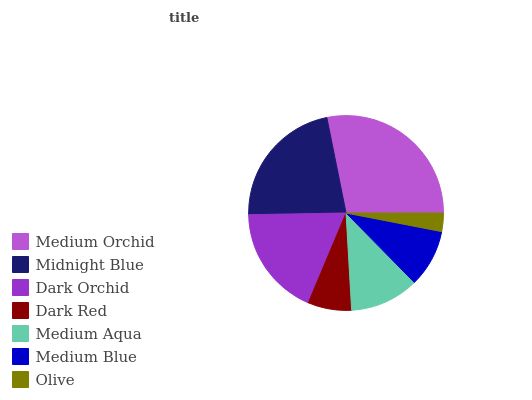Is Olive the minimum?
Answer yes or no. Yes. Is Medium Orchid the maximum?
Answer yes or no. Yes. Is Midnight Blue the minimum?
Answer yes or no. No. Is Midnight Blue the maximum?
Answer yes or no. No. Is Medium Orchid greater than Midnight Blue?
Answer yes or no. Yes. Is Midnight Blue less than Medium Orchid?
Answer yes or no. Yes. Is Midnight Blue greater than Medium Orchid?
Answer yes or no. No. Is Medium Orchid less than Midnight Blue?
Answer yes or no. No. Is Medium Aqua the high median?
Answer yes or no. Yes. Is Medium Aqua the low median?
Answer yes or no. Yes. Is Medium Orchid the high median?
Answer yes or no. No. Is Medium Orchid the low median?
Answer yes or no. No. 